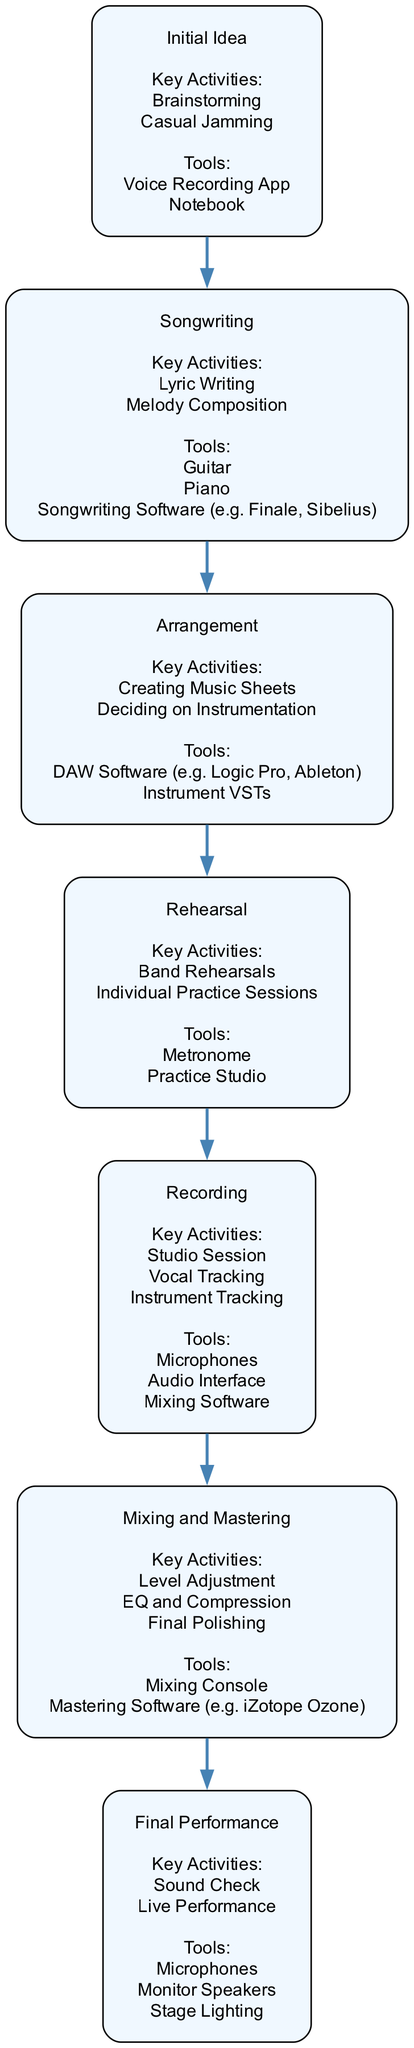What is the first step in the music collaboration workflow? The diagram indicates "Initial Idea" as the first element in the flow, representing the starting point of musical collaboration.
Answer: Initial Idea How many key activities are listed for the "Songwriting" node? Looking at the "Songwriting" node, there are two key activities: Lyric Writing and Melody Composition.
Answer: 2 What tool is used in the "Rehearsal" phase? The diagram shows both Metronome and Practice Studio as tools used in the "Rehearsal" phase.
Answer: Metronome What is the output of the "Mixing and Mastering" stage? The "Mixing and Mastering" stage involves several key activities, including Level Adjustment, EQ and Compression, and Final Polishing, which refine the sound of the recorded tracks.
Answer: Final Polishing List two key activities in the "Final Performance" step. Looking closely at the "Final Performance" node, we find Sound Check and Live Performance as key activities that take place.
Answer: Sound Check, Live Performance Which phase comes directly after "Arrangement"? In the sequence of the diagram, "Rehearsal" is the phase that follows "Arrangement," indicating the next step in the workflow.
Answer: Rehearsal How many tools are listed for the "Recording" phase? The "Recording" phase includes three tools: Microphones, Audio Interface, and Mixing Software, which are necessary for capturing the audio.
Answer: 3 What do we adjust during the "Mixing and Mastering" phase? The activities highlighted in this phase indicate that we adjust Levels, apply EQ and Compression, and perform Final Polishing of the audio tracks to enhance quality.
Answer: Levels What is the relationship between "Arrangement" and "Recording"? The diagram suggests a direct flow from "Arrangement" to "Recording," indicating that the arrangement of instrumental and vocal parts leads directly into the recording stage.
Answer: Direct flow 